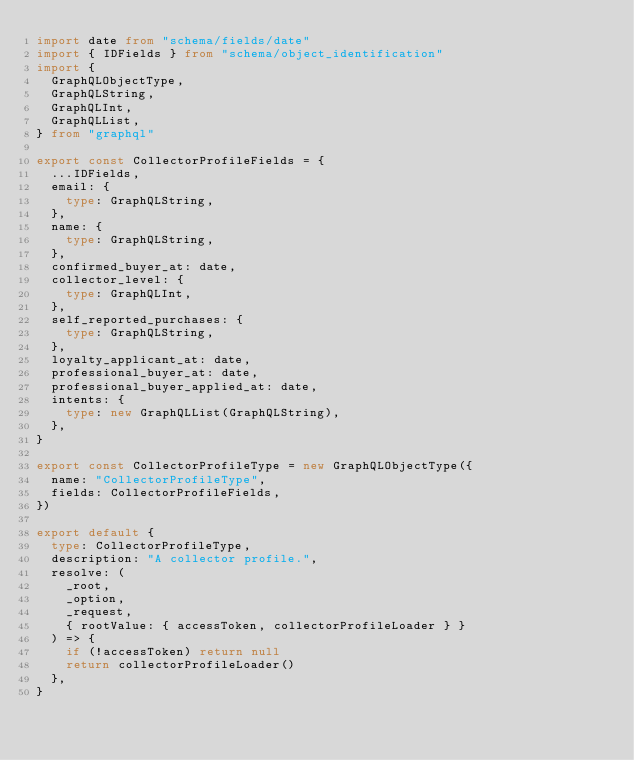Convert code to text. <code><loc_0><loc_0><loc_500><loc_500><_TypeScript_>import date from "schema/fields/date"
import { IDFields } from "schema/object_identification"
import {
  GraphQLObjectType,
  GraphQLString,
  GraphQLInt,
  GraphQLList,
} from "graphql"

export const CollectorProfileFields = {
  ...IDFields,
  email: {
    type: GraphQLString,
  },
  name: {
    type: GraphQLString,
  },
  confirmed_buyer_at: date,
  collector_level: {
    type: GraphQLInt,
  },
  self_reported_purchases: {
    type: GraphQLString,
  },
  loyalty_applicant_at: date,
  professional_buyer_at: date,
  professional_buyer_applied_at: date,
  intents: {
    type: new GraphQLList(GraphQLString),
  },
}

export const CollectorProfileType = new GraphQLObjectType({
  name: "CollectorProfileType",
  fields: CollectorProfileFields,
})

export default {
  type: CollectorProfileType,
  description: "A collector profile.",
  resolve: (
    _root,
    _option,
    _request,
    { rootValue: { accessToken, collectorProfileLoader } }
  ) => {
    if (!accessToken) return null
    return collectorProfileLoader()
  },
}
</code> 